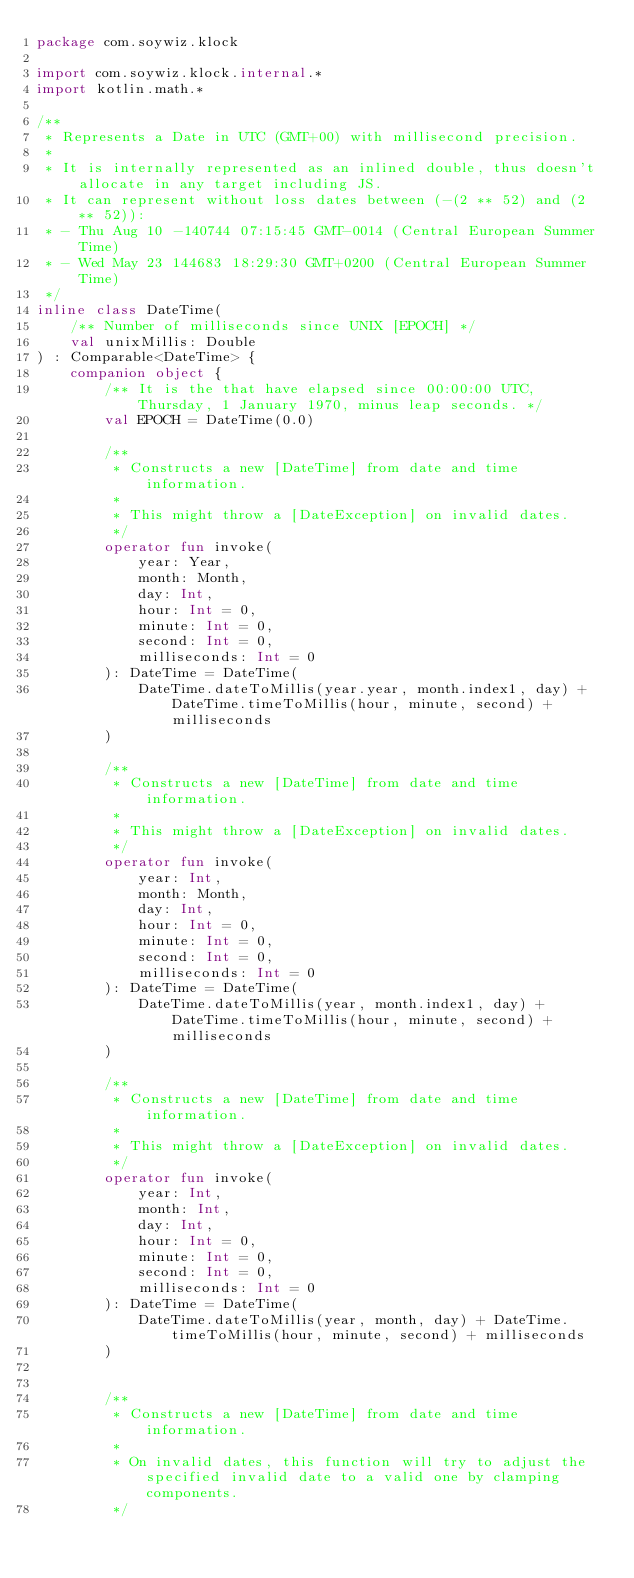Convert code to text. <code><loc_0><loc_0><loc_500><loc_500><_Kotlin_>package com.soywiz.klock

import com.soywiz.klock.internal.*
import kotlin.math.*

/**
 * Represents a Date in UTC (GMT+00) with millisecond precision.
 *
 * It is internally represented as an inlined double, thus doesn't allocate in any target including JS.
 * It can represent without loss dates between (-(2 ** 52) and (2 ** 52)):
 * - Thu Aug 10 -140744 07:15:45 GMT-0014 (Central European Summer Time)
 * - Wed May 23 144683 18:29:30 GMT+0200 (Central European Summer Time)
 */
inline class DateTime(
    /** Number of milliseconds since UNIX [EPOCH] */
    val unixMillis: Double
) : Comparable<DateTime> {
    companion object {
        /** It is the that have elapsed since 00:00:00 UTC, Thursday, 1 January 1970, minus leap seconds. */
        val EPOCH = DateTime(0.0)

        /**
         * Constructs a new [DateTime] from date and time information.
         *
         * This might throw a [DateException] on invalid dates.
         */
        operator fun invoke(
            year: Year,
            month: Month,
            day: Int,
            hour: Int = 0,
            minute: Int = 0,
            second: Int = 0,
            milliseconds: Int = 0
        ): DateTime = DateTime(
            DateTime.dateToMillis(year.year, month.index1, day) + DateTime.timeToMillis(hour, minute, second) + milliseconds
        )

        /**
         * Constructs a new [DateTime] from date and time information.
         *
         * This might throw a [DateException] on invalid dates.
         */
        operator fun invoke(
            year: Int,
            month: Month,
            day: Int,
            hour: Int = 0,
            minute: Int = 0,
            second: Int = 0,
            milliseconds: Int = 0
        ): DateTime = DateTime(
            DateTime.dateToMillis(year, month.index1, day) + DateTime.timeToMillis(hour, minute, second) + milliseconds
        )

        /**
         * Constructs a new [DateTime] from date and time information.
         *
         * This might throw a [DateException] on invalid dates.
         */
        operator fun invoke(
            year: Int,
            month: Int,
            day: Int,
            hour: Int = 0,
            minute: Int = 0,
            second: Int = 0,
            milliseconds: Int = 0
        ): DateTime = DateTime(
            DateTime.dateToMillis(year, month, day) + DateTime.timeToMillis(hour, minute, second) + milliseconds
        )


        /**
         * Constructs a new [DateTime] from date and time information.
         *
         * On invalid dates, this function will try to adjust the specified invalid date to a valid one by clamping components.
         */</code> 